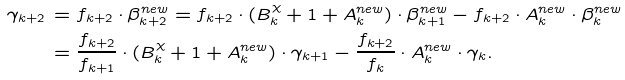Convert formula to latex. <formula><loc_0><loc_0><loc_500><loc_500>\gamma _ { k + 2 } & \, = f _ { k + 2 } \cdot \beta ^ { n e w } _ { k + 2 } = f _ { k + 2 } \cdot ( B ^ { \chi } _ { k } + 1 + A ^ { n e w } _ { k } ) \cdot \beta ^ { n e w } _ { k + 1 } - f _ { k + 2 } \cdot A ^ { n e w } _ { k } \cdot \beta ^ { n e w } _ { k } \\ & \, = \frac { f _ { k + 2 } } { f _ { k + 1 } } \cdot ( B ^ { \chi } _ { k } + 1 + A ^ { n e w } _ { k } ) \cdot \gamma _ { k + 1 } - \frac { f _ { k + 2 } } { f _ { k } } \cdot A ^ { n e w } _ { k } \cdot \gamma _ { k } .</formula> 